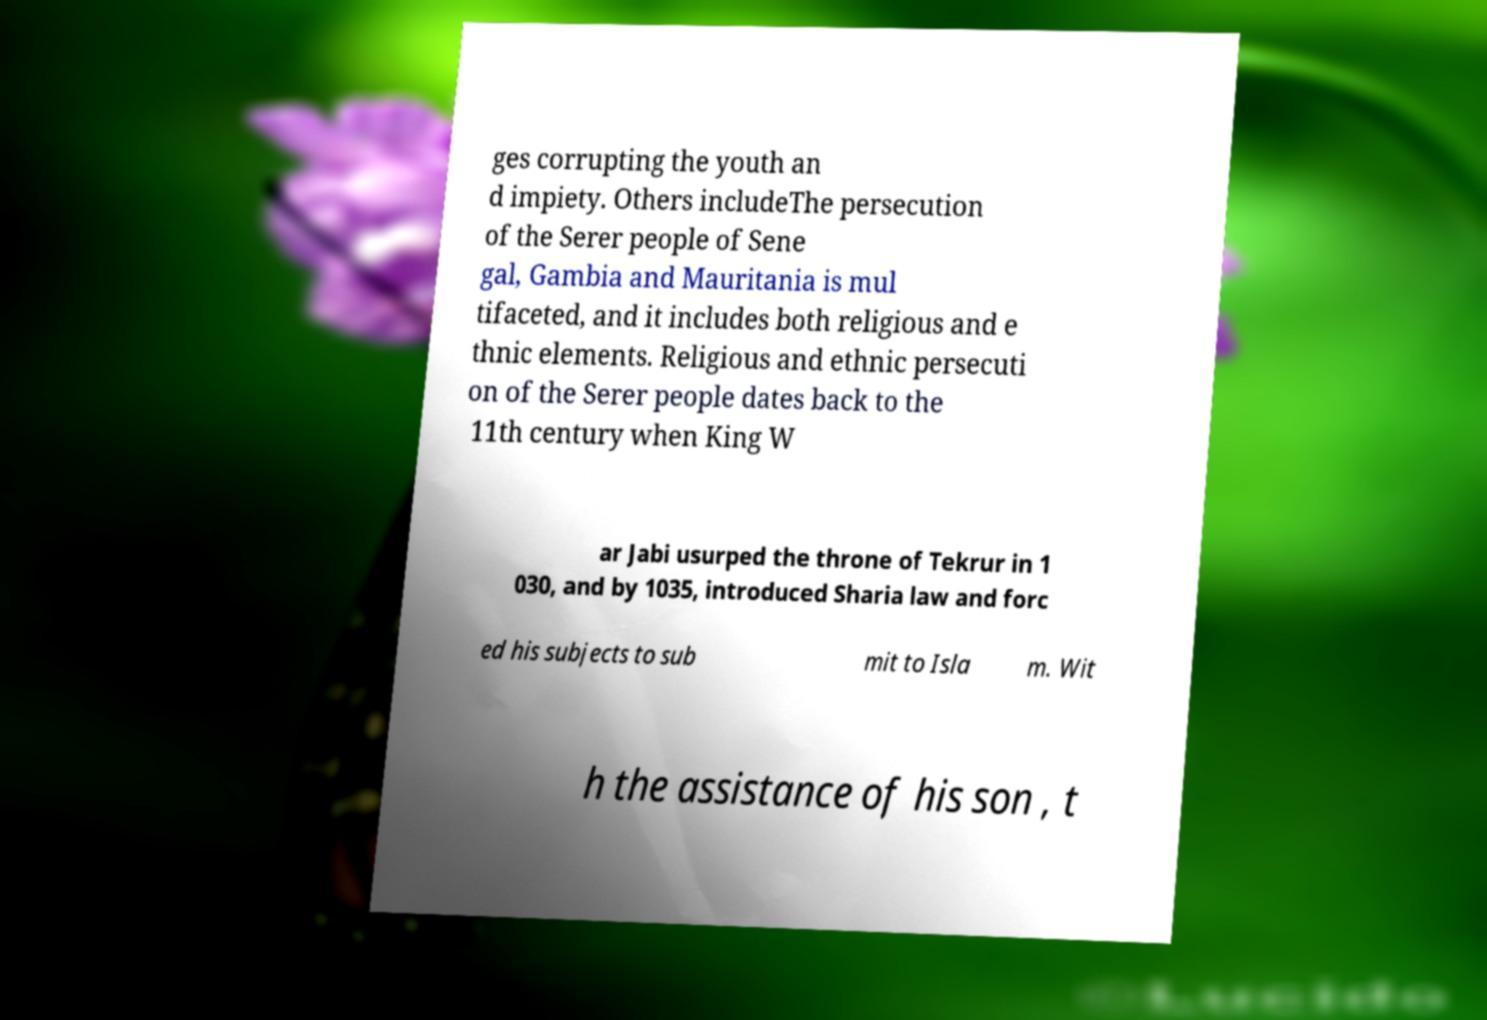Can you accurately transcribe the text from the provided image for me? ges corrupting the youth an d impiety. Others includeThe persecution of the Serer people of Sene gal, Gambia and Mauritania is mul tifaceted, and it includes both religious and e thnic elements. Religious and ethnic persecuti on of the Serer people dates back to the 11th century when King W ar Jabi usurped the throne of Tekrur in 1 030, and by 1035, introduced Sharia law and forc ed his subjects to sub mit to Isla m. Wit h the assistance of his son , t 